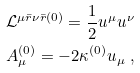<formula> <loc_0><loc_0><loc_500><loc_500>\mathcal { L } ^ { \mu \bar { r } \nu \bar { r } ( 0 ) } = \frac { 1 } { 2 } u ^ { \mu } u ^ { \nu } \\ A ^ { ( 0 ) } _ { \mu } = - 2 \kappa ^ { ( 0 ) } u _ { \mu } \ ,</formula> 